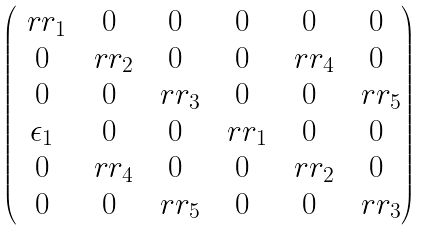<formula> <loc_0><loc_0><loc_500><loc_500>\begin{pmatrix} \ r r _ { 1 } & 0 & 0 & 0 & 0 & 0 \\ 0 & \ r r _ { 2 } & 0 & 0 & \ r r _ { 4 } & 0 \\ 0 & 0 & \ r r _ { 3 } & 0 & 0 & \ r r _ { 5 } \\ \epsilon _ { 1 } & 0 & 0 & \ r r _ { 1 } & 0 & 0 \\ 0 & \ r r _ { 4 } & 0 & 0 & \ r r _ { 2 } & 0 \\ 0 & 0 & \ r r _ { 5 } & 0 & 0 & \ r r _ { 3 } \end{pmatrix}</formula> 